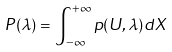Convert formula to latex. <formula><loc_0><loc_0><loc_500><loc_500>P ( \lambda ) = \int _ { - \infty } ^ { + \infty } p ( U , \lambda ) d X</formula> 